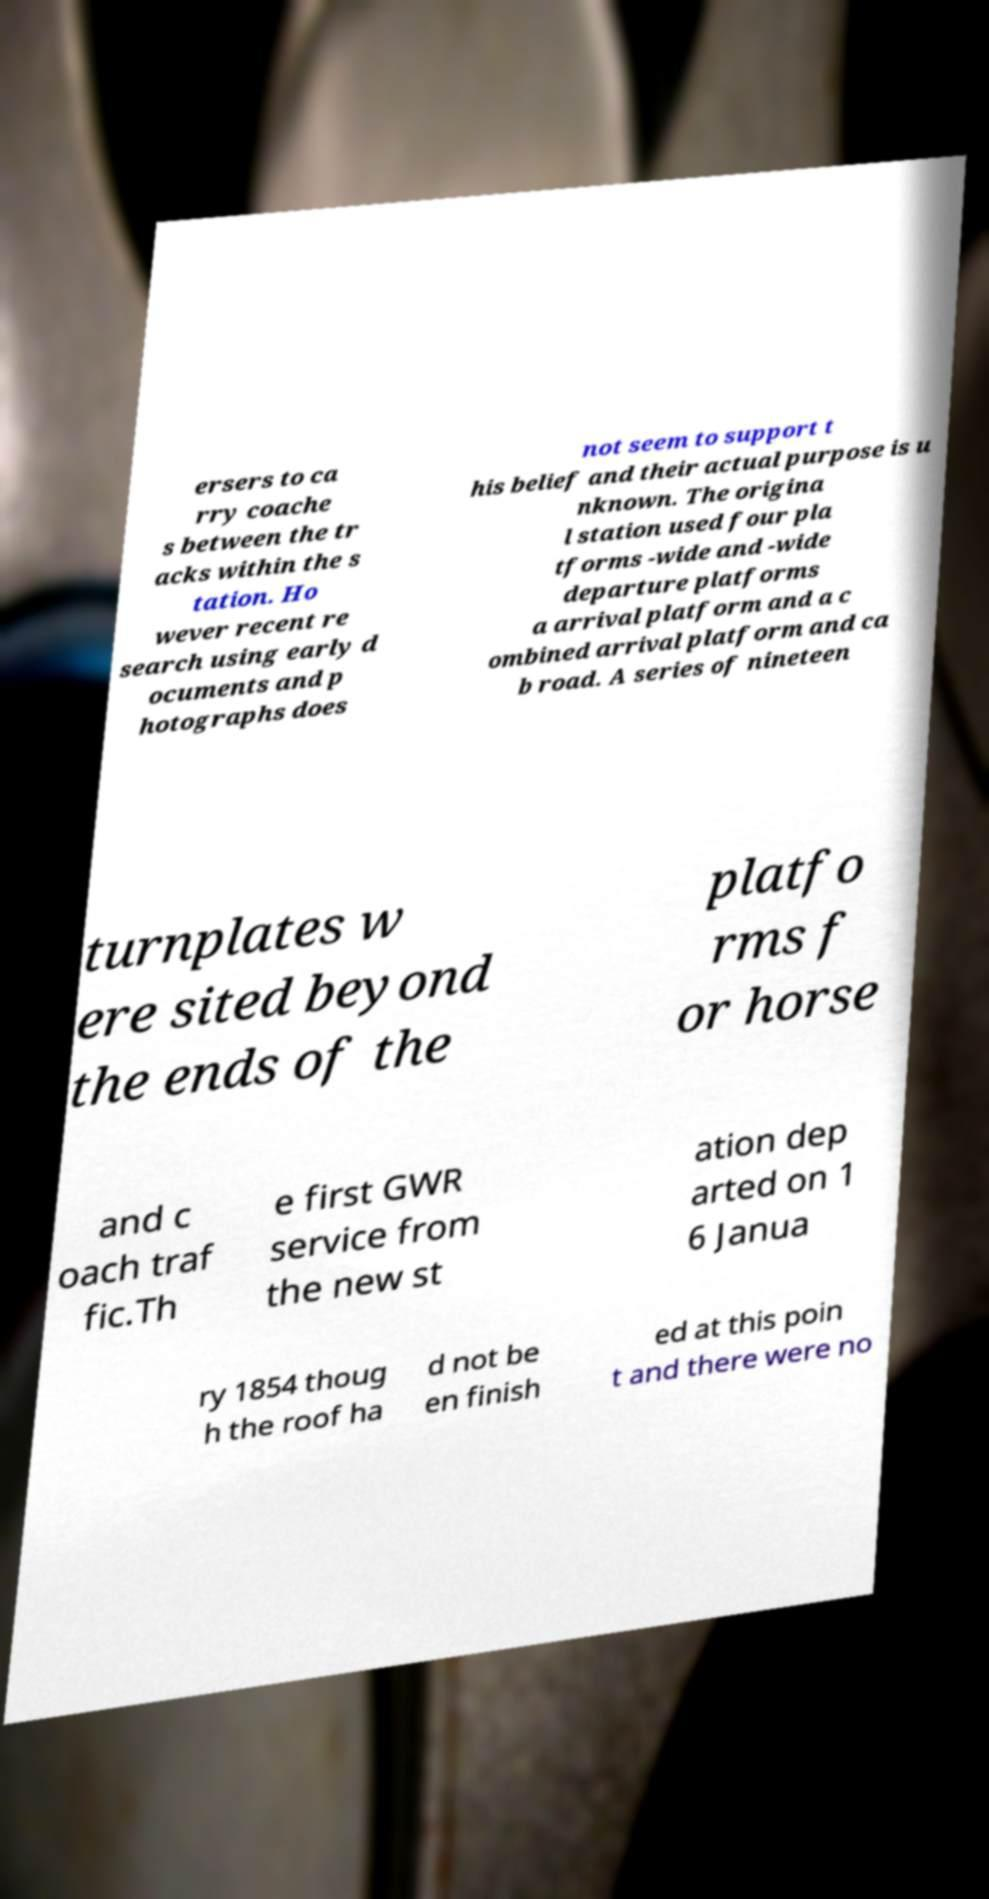Please identify and transcribe the text found in this image. ersers to ca rry coache s between the tr acks within the s tation. Ho wever recent re search using early d ocuments and p hotographs does not seem to support t his belief and their actual purpose is u nknown. The origina l station used four pla tforms -wide and -wide departure platforms a arrival platform and a c ombined arrival platform and ca b road. A series of nineteen turnplates w ere sited beyond the ends of the platfo rms f or horse and c oach traf fic.Th e first GWR service from the new st ation dep arted on 1 6 Janua ry 1854 thoug h the roof ha d not be en finish ed at this poin t and there were no 